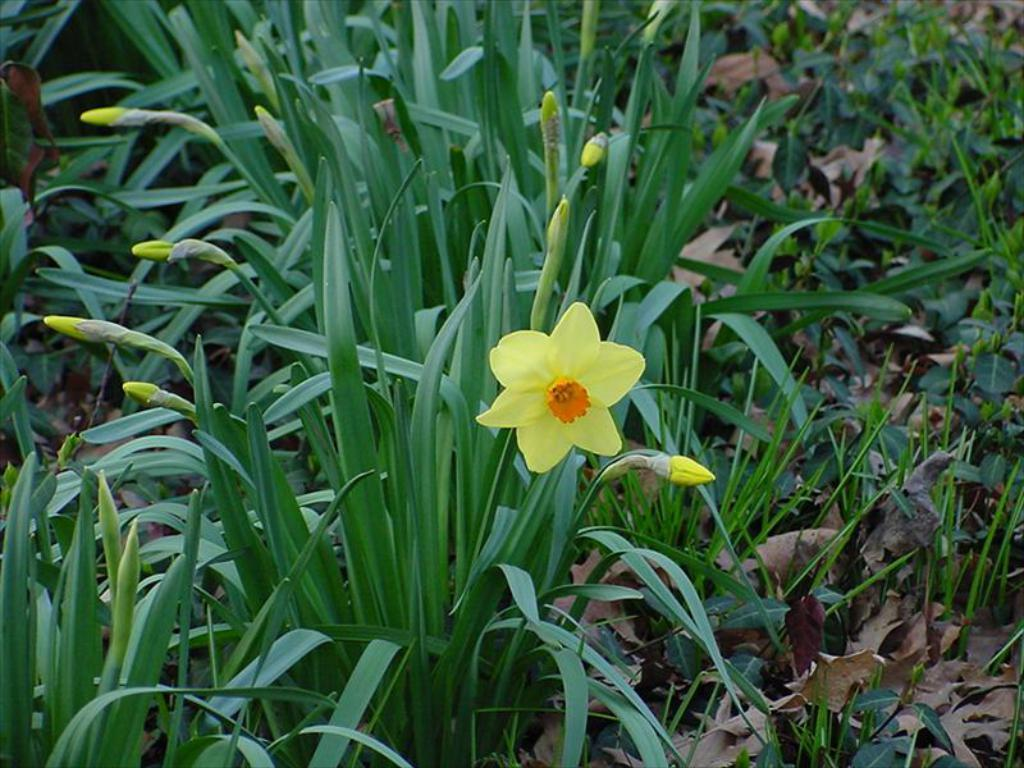What type of vegetation can be seen in the image? There is grass in the image. What other type of plant can be seen in the image? There is a plant in the image. What kind of floral element is present in the image? There is a flower in the image. What type of guide can be seen leading a group of explorers in the image? There is no guide or group of explorers present in the image; it features grass, a plant, and a flower. What type of dinner is being served on the table in the image? There is no dinner or table present in the image. 